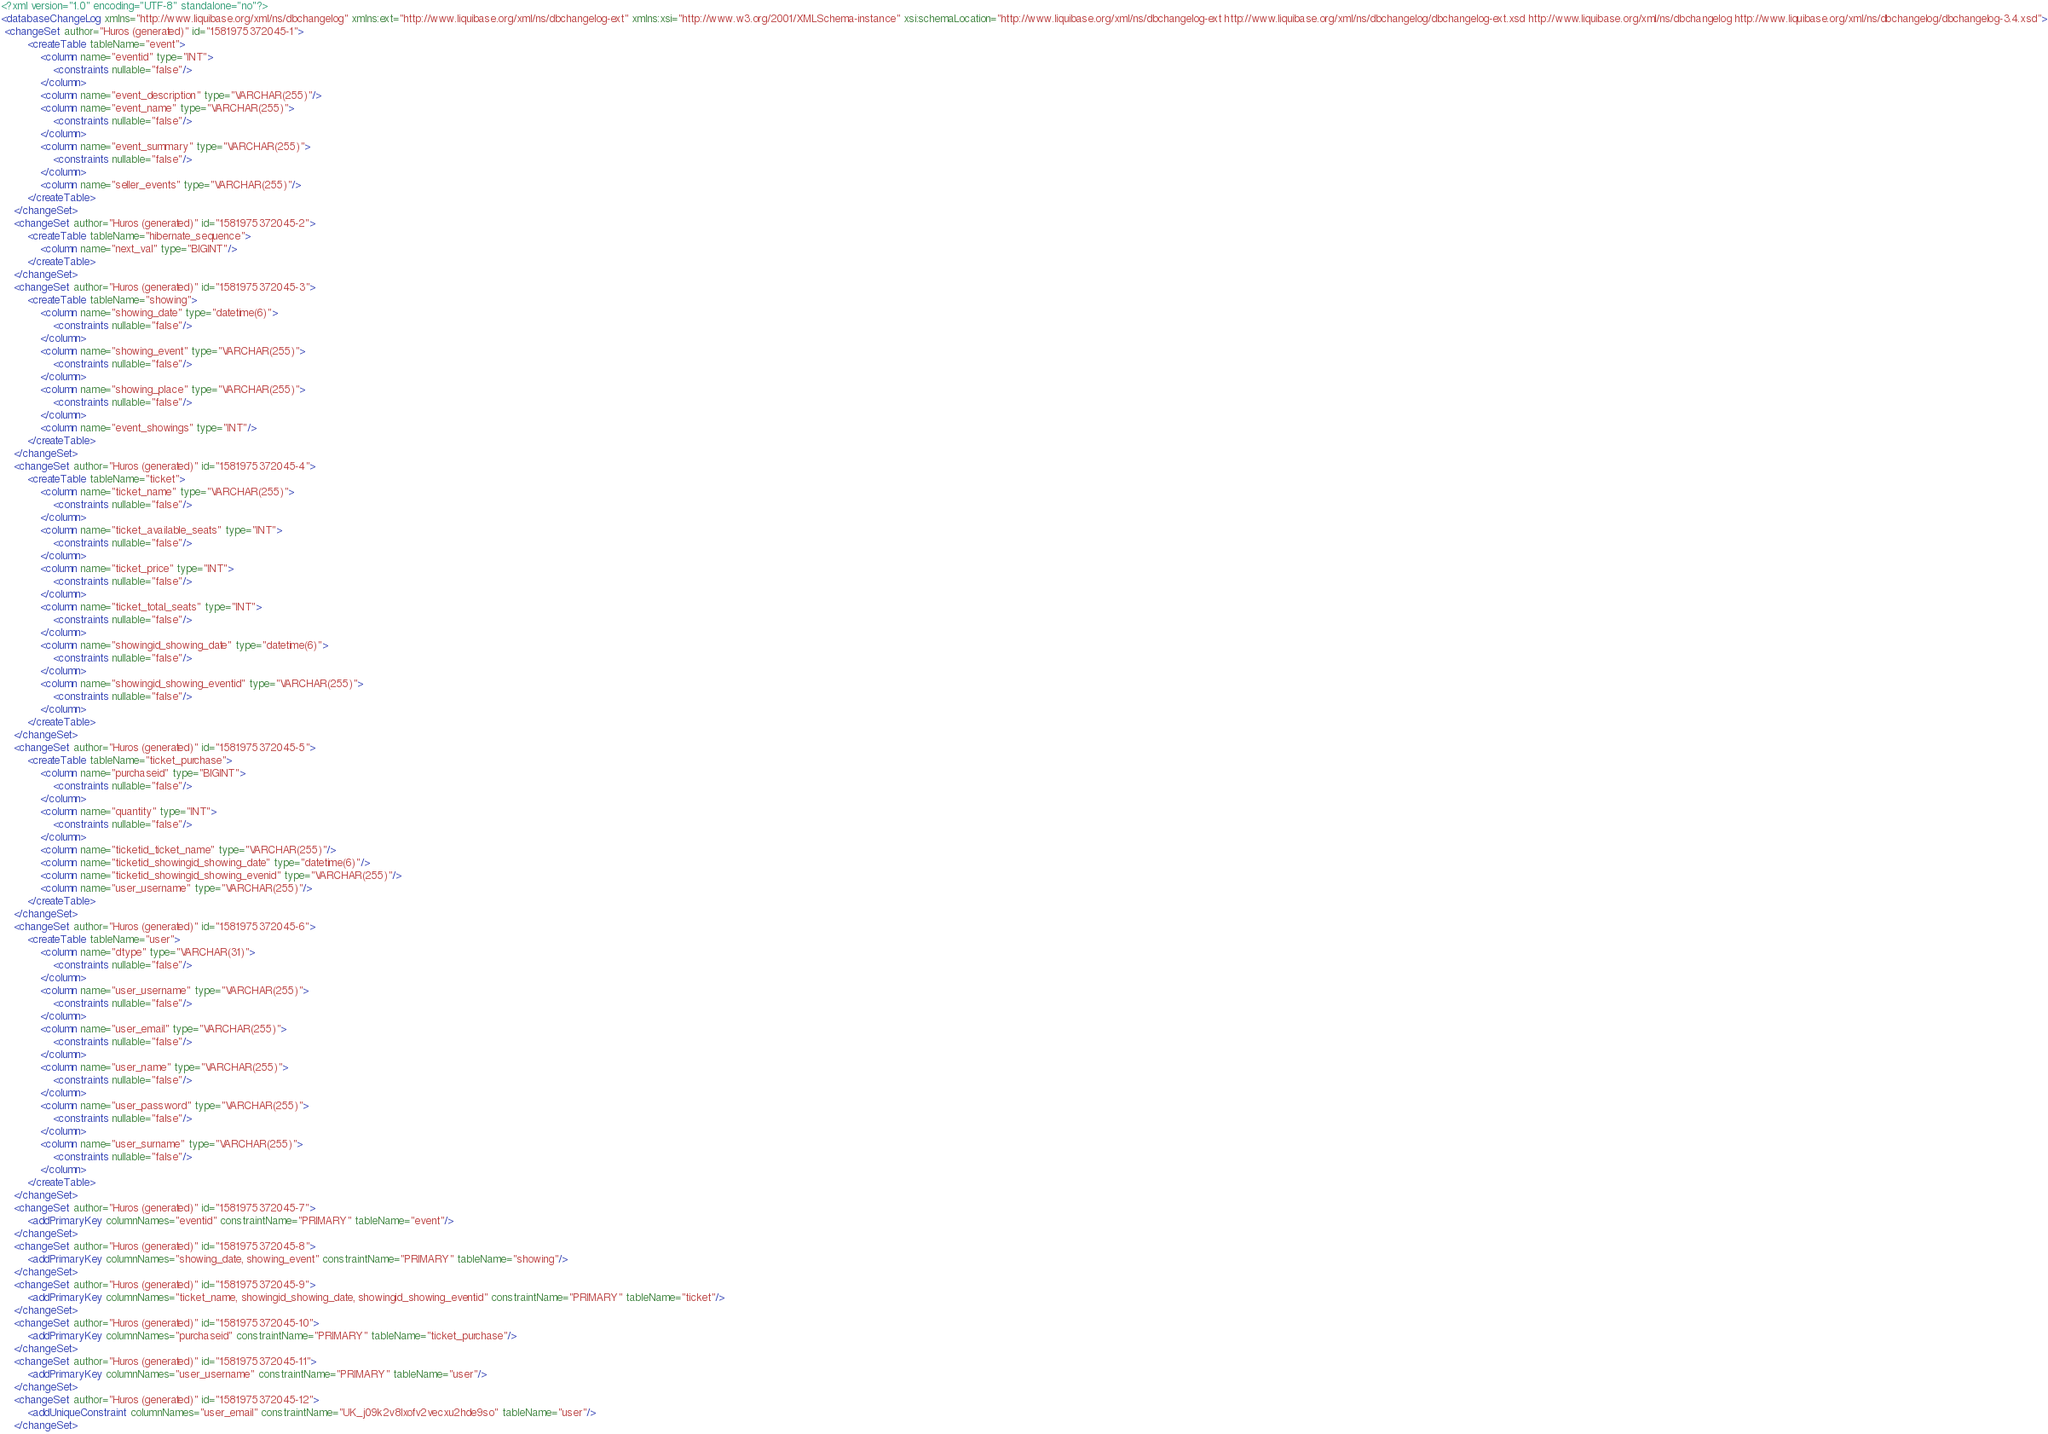Convert code to text. <code><loc_0><loc_0><loc_500><loc_500><_XML_><?xml version="1.0" encoding="UTF-8" standalone="no"?>
<databaseChangeLog xmlns="http://www.liquibase.org/xml/ns/dbchangelog" xmlns:ext="http://www.liquibase.org/xml/ns/dbchangelog-ext" xmlns:xsi="http://www.w3.org/2001/XMLSchema-instance" xsi:schemaLocation="http://www.liquibase.org/xml/ns/dbchangelog-ext http://www.liquibase.org/xml/ns/dbchangelog/dbchangelog-ext.xsd http://www.liquibase.org/xml/ns/dbchangelog http://www.liquibase.org/xml/ns/dbchangelog/dbchangelog-3.4.xsd">
 <changeSet author="Huros (generated)" id="1581975372045-1">
        <createTable tableName="event">
            <column name="eventid" type="INT">
                <constraints nullable="false"/>
            </column>
            <column name="event_description" type="VARCHAR(255)"/>
            <column name="event_name" type="VARCHAR(255)">
                <constraints nullable="false"/>
            </column>
            <column name="event_summary" type="VARCHAR(255)">
                <constraints nullable="false"/>
            </column>
            <column name="seller_events" type="VARCHAR(255)"/>
        </createTable>
    </changeSet>
    <changeSet author="Huros (generated)" id="1581975372045-2">
        <createTable tableName="hibernate_sequence">
            <column name="next_val" type="BIGINT"/>
        </createTable>
    </changeSet>
    <changeSet author="Huros (generated)" id="1581975372045-3">
        <createTable tableName="showing">
            <column name="showing_date" type="datetime(6)">
                <constraints nullable="false"/>
            </column>
            <column name="showing_event" type="VARCHAR(255)">
                <constraints nullable="false"/>
            </column>
            <column name="showing_place" type="VARCHAR(255)">
                <constraints nullable="false"/>
            </column>
            <column name="event_showings" type="INT"/>
        </createTable>
    </changeSet>
    <changeSet author="Huros (generated)" id="1581975372045-4">
        <createTable tableName="ticket">
            <column name="ticket_name" type="VARCHAR(255)">
                <constraints nullable="false"/>
            </column>
            <column name="ticket_available_seats" type="INT">
                <constraints nullable="false"/>
            </column>
            <column name="ticket_price" type="INT">
                <constraints nullable="false"/>
            </column>
            <column name="ticket_total_seats" type="INT">
                <constraints nullable="false"/>
            </column>
            <column name="showingid_showing_date" type="datetime(6)">
                <constraints nullable="false"/>
            </column>
            <column name="showingid_showing_eventid" type="VARCHAR(255)">
                <constraints nullable="false"/>
            </column>
        </createTable>
    </changeSet>
    <changeSet author="Huros (generated)" id="1581975372045-5">
        <createTable tableName="ticket_purchase">
            <column name="purchaseid" type="BIGINT">
                <constraints nullable="false"/>
            </column>
            <column name="quantity" type="INT">
                <constraints nullable="false"/>
            </column>
            <column name="ticketid_ticket_name" type="VARCHAR(255)"/>
            <column name="ticketid_showingid_showing_date" type="datetime(6)"/>
            <column name="ticketid_showingid_showing_evenid" type="VARCHAR(255)"/>
            <column name="user_username" type="VARCHAR(255)"/>
        </createTable>
    </changeSet>
    <changeSet author="Huros (generated)" id="1581975372045-6">
        <createTable tableName="user">
            <column name="dtype" type="VARCHAR(31)">
                <constraints nullable="false"/>
            </column>
            <column name="user_username" type="VARCHAR(255)">
                <constraints nullable="false"/>
            </column>
            <column name="user_email" type="VARCHAR(255)">
                <constraints nullable="false"/>
            </column>
            <column name="user_name" type="VARCHAR(255)">
                <constraints nullable="false"/>
            </column>
            <column name="user_password" type="VARCHAR(255)">
                <constraints nullable="false"/>
            </column>
            <column name="user_surname" type="VARCHAR(255)">
                <constraints nullable="false"/>
            </column>
        </createTable>
    </changeSet>
    <changeSet author="Huros (generated)" id="1581975372045-7">
        <addPrimaryKey columnNames="eventid" constraintName="PRIMARY" tableName="event"/>
    </changeSet>
    <changeSet author="Huros (generated)" id="1581975372045-8">
        <addPrimaryKey columnNames="showing_date, showing_event" constraintName="PRIMARY" tableName="showing"/>
    </changeSet>
    <changeSet author="Huros (generated)" id="1581975372045-9">
        <addPrimaryKey columnNames="ticket_name, showingid_showing_date, showingid_showing_eventid" constraintName="PRIMARY" tableName="ticket"/>
    </changeSet>
    <changeSet author="Huros (generated)" id="1581975372045-10">
        <addPrimaryKey columnNames="purchaseid" constraintName="PRIMARY" tableName="ticket_purchase"/>
    </changeSet>
    <changeSet author="Huros (generated)" id="1581975372045-11">
        <addPrimaryKey columnNames="user_username" constraintName="PRIMARY" tableName="user"/>
    </changeSet>
    <changeSet author="Huros (generated)" id="1581975372045-12">
        <addUniqueConstraint columnNames="user_email" constraintName="UK_j09k2v8lxofv2vecxu2hde9so" tableName="user"/>
    </changeSet></code> 